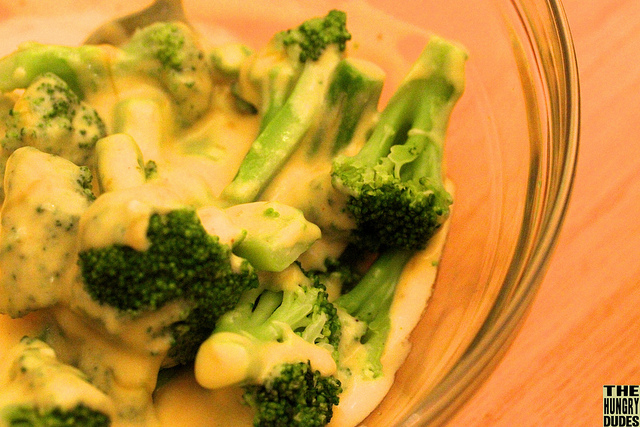Extract all visible text content from this image. THE HUNGRY DUDES 